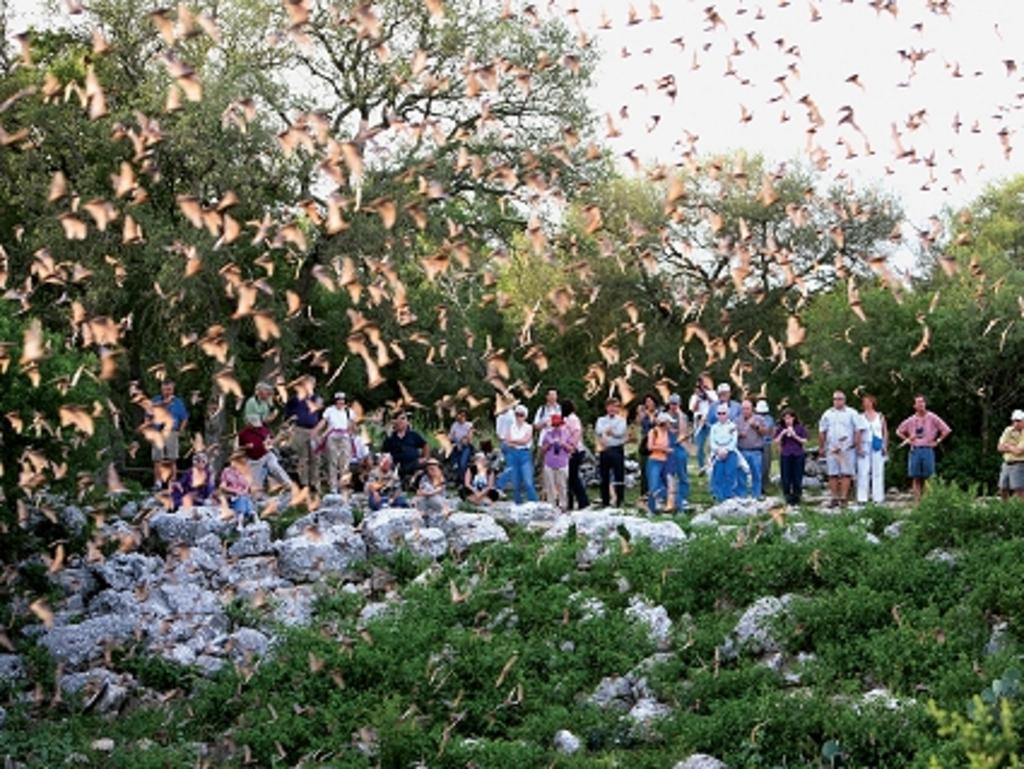Please provide a concise description of this image. In the picture we can see, full of plants and white colored flowers to it and behind it, we can see some people are standing and watching the birds which are flying and the birds are cream in color and behind the people we can see full of trees and sky. 